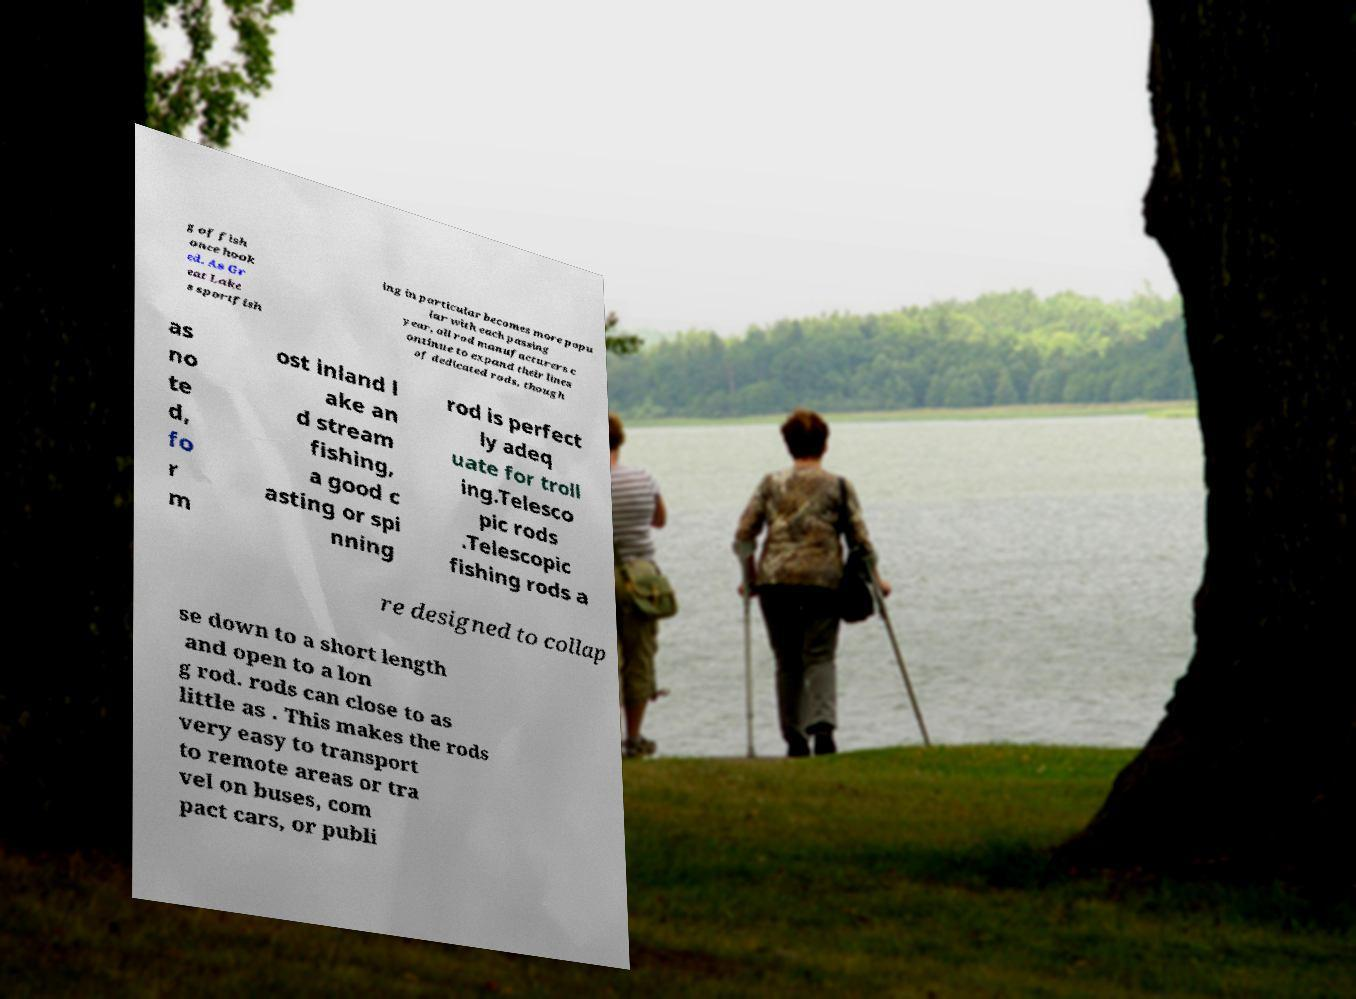Could you assist in decoding the text presented in this image and type it out clearly? g of fish once hook ed. As Gr eat Lake s sportfish ing in particular becomes more popu lar with each passing year, all rod manufacturers c ontinue to expand their lines of dedicated rods, though as no te d, fo r m ost inland l ake an d stream fishing, a good c asting or spi nning rod is perfect ly adeq uate for troll ing.Telesco pic rods .Telescopic fishing rods a re designed to collap se down to a short length and open to a lon g rod. rods can close to as little as . This makes the rods very easy to transport to remote areas or tra vel on buses, com pact cars, or publi 